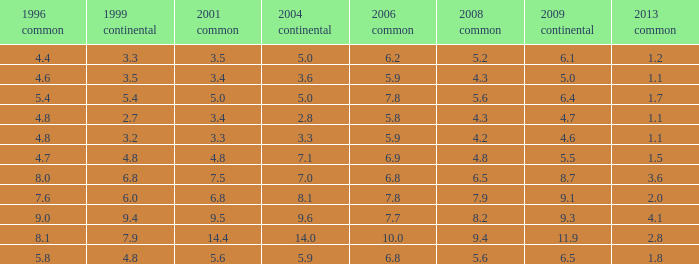What is the lowest value for 2004 European when 1999 European is 3.3 and less than 4.4 in 1996 general? None. 